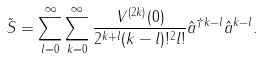<formula> <loc_0><loc_0><loc_500><loc_500>\tilde { S } = \sum _ { l = 0 } ^ { \infty } \sum _ { k = 0 } ^ { \infty } \frac { V ^ { ( 2 k ) } ( 0 ) } { 2 ^ { k + l } ( k - l ) ! ^ { 2 } l ! } \hat { a } ^ { \dagger k - l } \hat { a } ^ { k - l } .</formula> 